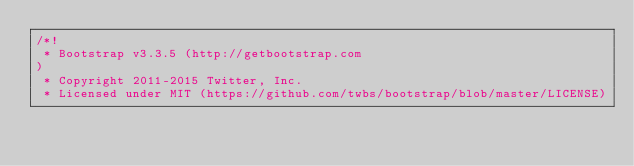Convert code to text. <code><loc_0><loc_0><loc_500><loc_500><_CSS_>/*!
 * Bootstrap v3.3.5 (http://getbootstrap.com
)
 * Copyright 2011-2015 Twitter, Inc.
 * Licensed under MIT (https://github.com/twbs/bootstrap/blob/master/LICENSE)</code> 